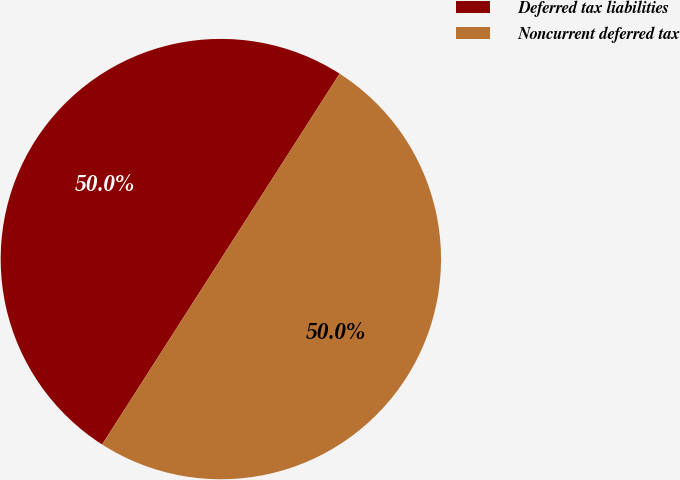Convert chart. <chart><loc_0><loc_0><loc_500><loc_500><pie_chart><fcel>Deferred tax liabilities<fcel>Noncurrent deferred tax<nl><fcel>50.0%<fcel>50.0%<nl></chart> 